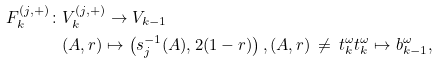<formula> <loc_0><loc_0><loc_500><loc_500>F ^ { ( j , + ) } _ { k } \colon & V ^ { ( j , + ) } _ { k } \to V _ { k - 1 } \\ & ( A , r ) \mapsto \left ( s _ { j } ^ { - 1 } ( A ) , 2 ( 1 - r ) \right ) , ( A , r ) \, \not = \, t _ { k } ^ { \omega } t _ { k } ^ { \omega } \mapsto b _ { k - 1 } ^ { \omega } ,</formula> 